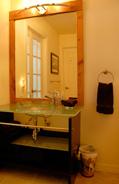Is the photo blurry?
Answer briefly. Yes. Is there any glass in this picture?
Keep it brief. Yes. Is the trash can on the right or left side of the picture?
Write a very short answer. Right. What color are the lights?
Answer briefly. Yellow. 